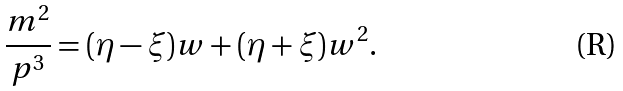<formula> <loc_0><loc_0><loc_500><loc_500>\frac { m ^ { 2 } } { p ^ { 3 } } = ( \eta - \xi ) w + ( \eta + \xi ) w ^ { 2 } .</formula> 